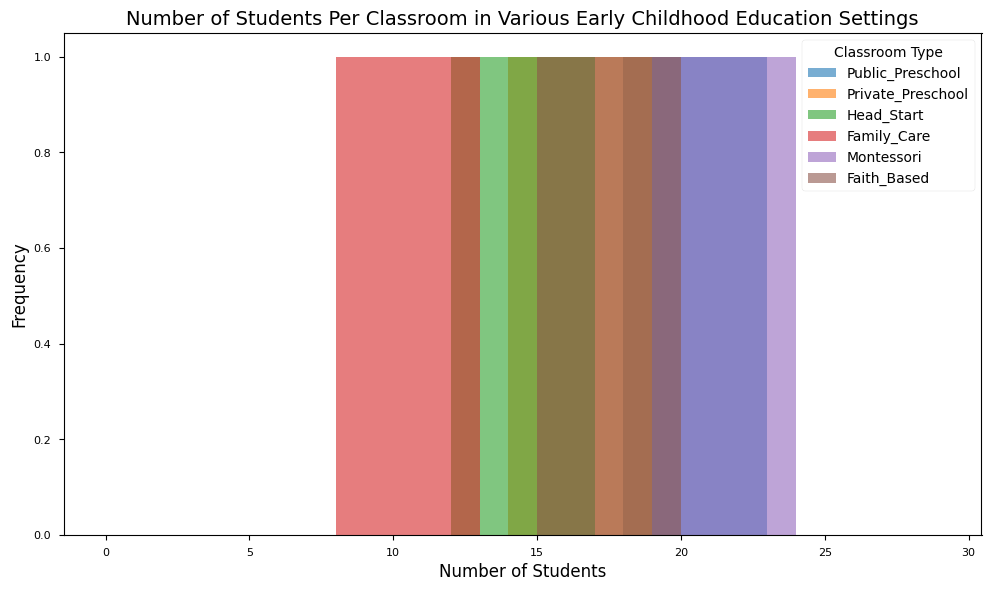How many classroom types are included in the figure? The legend in the figure lists the different types of classrooms, which are Public Preschool, Private Preschool, Head Start, Family Care, Montessori, and Faith-Based. Counting these types will give the number of classroom types.
Answer: 6 Which classroom type has the highest number of students? The histogram shows that the highest number of students appears in the range of 19 to 23, which is the color associated with Montessori classrooms in the legend.
Answer: Montessori What is the average number of students in Private Preschools? The histogram shows the number of students for Private Preschool classrooms: 14, 15, 16, 17, 18. Adding these together gives 80, and dividing by the number of data points (5) results in an average. (14 + 15 + 16 + 17 + 18) / 5 = 80 / 5
Answer: 16 Which classroom type has the smallest range of student numbers, and what is that range? By examining the histogram for the range of numbers covered by each classroom type’s bins, Family Care appears to have the smallest range (8 to 12). The range is calculated as 12 - 8.
Answer: Family Care, 4 How does the number of students in Public Preschools compare to that in Head Start programs? By comparing the histograms, Public Preschool has a range from 18 to 22, while Head Start ranges from 12 to 16. Public Preschool classrooms generally have a higher number of students compared to Head Start.
Answer: Public Preschools have more students Which classroom type has the most diverse number of students? Looking at the spread of each histogram, Montessori and Public Preschool seem to cover the widest range of student numbers. We can judge the diversity by the number of bins they occupy.
Answer: Montessori/Public Preschool What is the total number of students shown for Family Care settings? The histogram for Family Care shows the numbers 8, 9, 10, 11, 12. Summing these numbers gives (8 + 9 + 10 + 11 + 12) = 50.
Answer: 50 Which classroom type has its peak frequency at 18 students? The histogram shows that the bar corresponding to 18 students is highest for Public Preschool in its specific color.
Answer: Public Preschool How does the frequency distribution of students in Faith-Based settings compare to Private Preschools? Faith-Based settings show frequencies at 15, 16, 17, 18, 19 while Private Preschools show frequencies at 14, 15, 16, 17, 18. Both distributions are similar, but Faith-Based settings go slightly higher in student number.
Answer: Similar, Faith-Based has more students Is there any classroom type that does not overlap in student numbers with any other type? By examining the ranges displayed, every classroom type’s bins overlap with bins from other classroom types at some point in the histogram.
Answer: No 